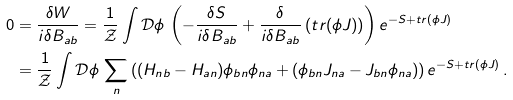<formula> <loc_0><loc_0><loc_500><loc_500>0 & = \frac { \delta W } { i \delta B _ { a b } } = \frac { 1 } { \mathcal { Z } } \int \mathcal { D } \phi \, \left ( - \frac { \delta S } { i \delta B _ { a b } } + \frac { \delta } { i \delta B _ { a b } } \left ( t r ( \phi J ) \right ) \right ) e ^ { - S + t r ( \phi J ) } \\ & = \frac { 1 } { \mathcal { Z } } \int \mathcal { D } \phi \, \sum _ { n } \left ( ( H _ { n b } - H _ { a n } ) \phi _ { b n } \phi _ { n a } + ( \phi _ { b n } J _ { n a } - J _ { b n } \phi _ { n a } ) \right ) e ^ { - S + t r ( \phi J ) } \, .</formula> 